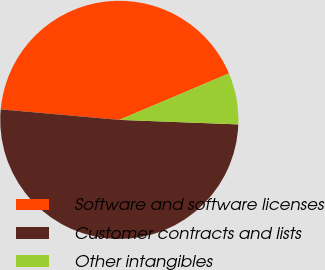Convert chart to OTSL. <chart><loc_0><loc_0><loc_500><loc_500><pie_chart><fcel>Software and software licenses<fcel>Customer contracts and lists<fcel>Other intangibles<nl><fcel>42.22%<fcel>50.8%<fcel>6.98%<nl></chart> 